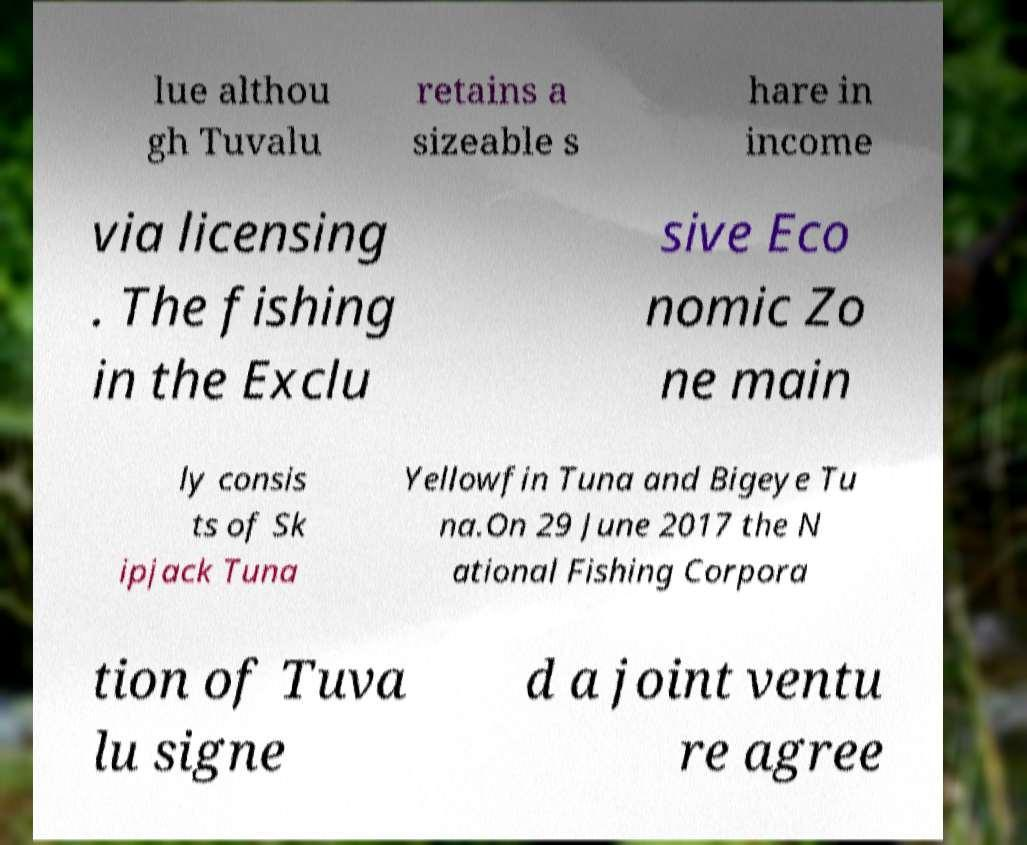Can you accurately transcribe the text from the provided image for me? lue althou gh Tuvalu retains a sizeable s hare in income via licensing . The fishing in the Exclu sive Eco nomic Zo ne main ly consis ts of Sk ipjack Tuna Yellowfin Tuna and Bigeye Tu na.On 29 June 2017 the N ational Fishing Corpora tion of Tuva lu signe d a joint ventu re agree 